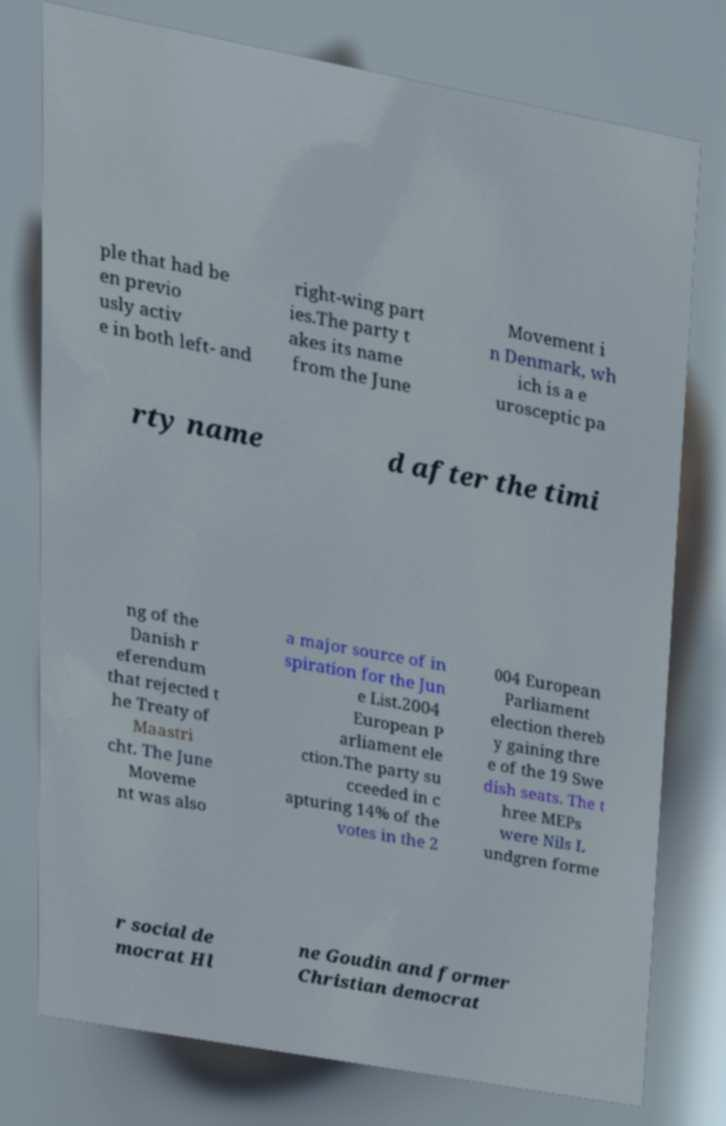For documentation purposes, I need the text within this image transcribed. Could you provide that? ple that had be en previo usly activ e in both left- and right-wing part ies.The party t akes its name from the June Movement i n Denmark, wh ich is a e urosceptic pa rty name d after the timi ng of the Danish r eferendum that rejected t he Treaty of Maastri cht. The June Moveme nt was also a major source of in spiration for the Jun e List.2004 European P arliament ele ction.The party su cceeded in c apturing 14% of the votes in the 2 004 European Parliament election thereb y gaining thre e of the 19 Swe dish seats. The t hree MEPs were Nils L undgren forme r social de mocrat Hl ne Goudin and former Christian democrat 